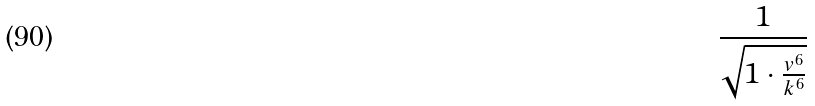Convert formula to latex. <formula><loc_0><loc_0><loc_500><loc_500>\frac { 1 } { \sqrt { 1 \cdot \frac { v ^ { 6 } } { k ^ { 6 } } } }</formula> 